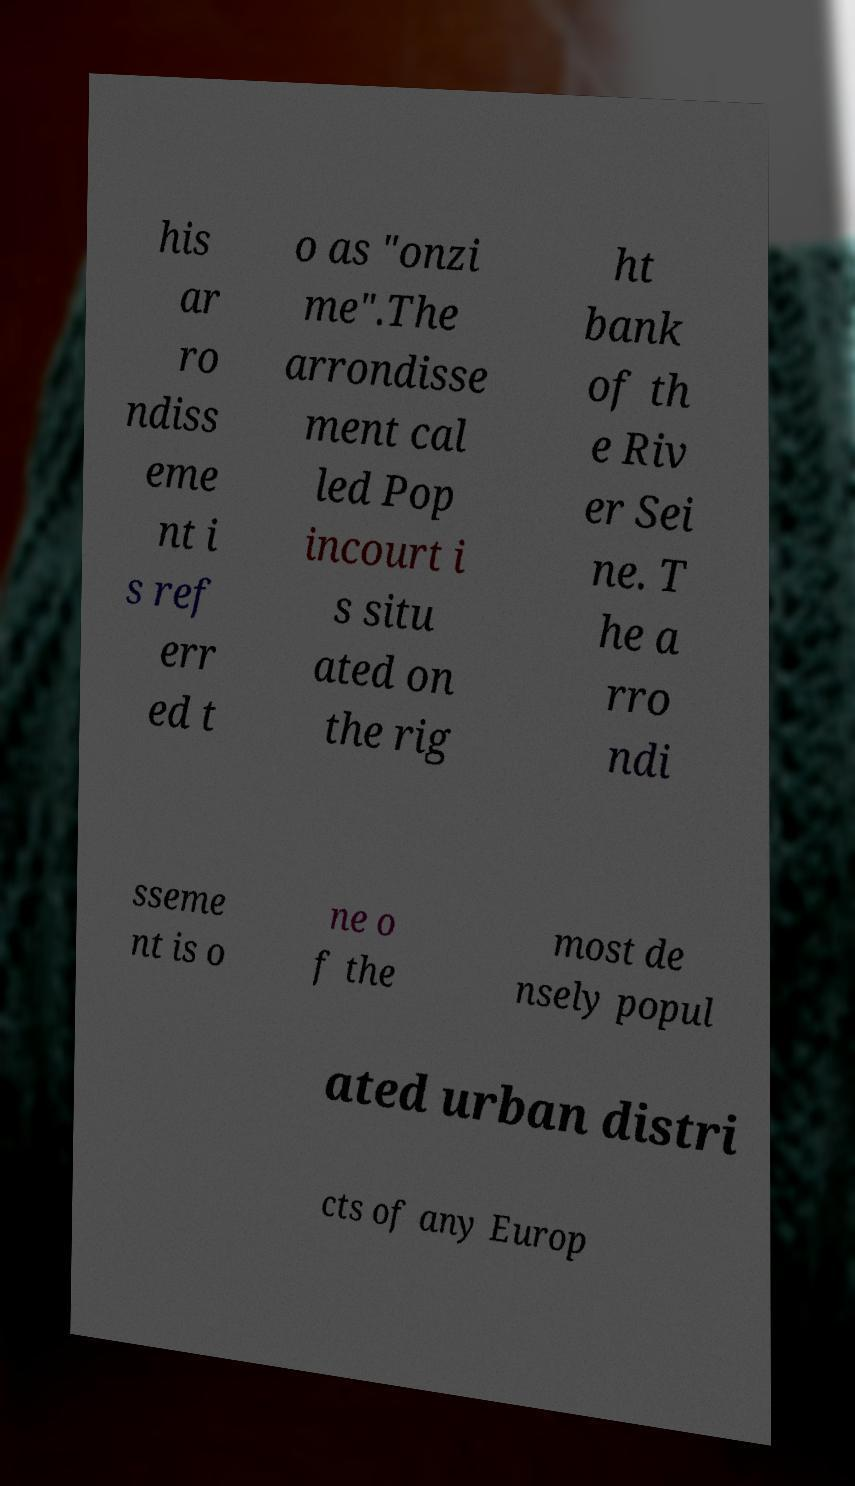Could you extract and type out the text from this image? his ar ro ndiss eme nt i s ref err ed t o as "onzi me".The arrondisse ment cal led Pop incourt i s situ ated on the rig ht bank of th e Riv er Sei ne. T he a rro ndi sseme nt is o ne o f the most de nsely popul ated urban distri cts of any Europ 